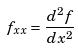Convert formula to latex. <formula><loc_0><loc_0><loc_500><loc_500>f _ { x x } = \frac { d ^ { 2 } f } { d x ^ { 2 } }</formula> 